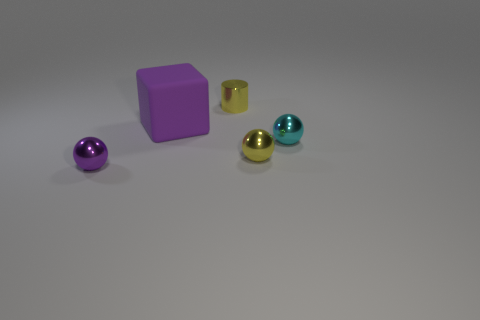The purple thing that is on the right side of the metallic sphere left of the purple rubber object is made of what material?
Your answer should be compact. Rubber. How many shiny things are tiny purple spheres or tiny blue blocks?
Ensure brevity in your answer.  1. How many metallic spheres have the same color as the matte cube?
Provide a short and direct response. 1. There is a yellow thing that is behind the tiny yellow sphere; are there any yellow spheres behind it?
Offer a very short reply. No. How many metal objects are in front of the yellow ball and behind the big purple thing?
Your answer should be compact. 0. What number of other large yellow cylinders are made of the same material as the yellow cylinder?
Give a very brief answer. 0. There is a purple thing behind the tiny ball that is on the left side of the purple cube; how big is it?
Offer a terse response. Large. Are there any tiny yellow shiny objects of the same shape as the cyan metallic thing?
Ensure brevity in your answer.  Yes. Do the thing that is left of the large purple rubber thing and the yellow thing that is behind the big purple block have the same size?
Offer a very short reply. Yes. Is the number of yellow shiny objects that are on the left side of the tiny yellow ball less than the number of purple matte things behind the small cylinder?
Your response must be concise. No. 